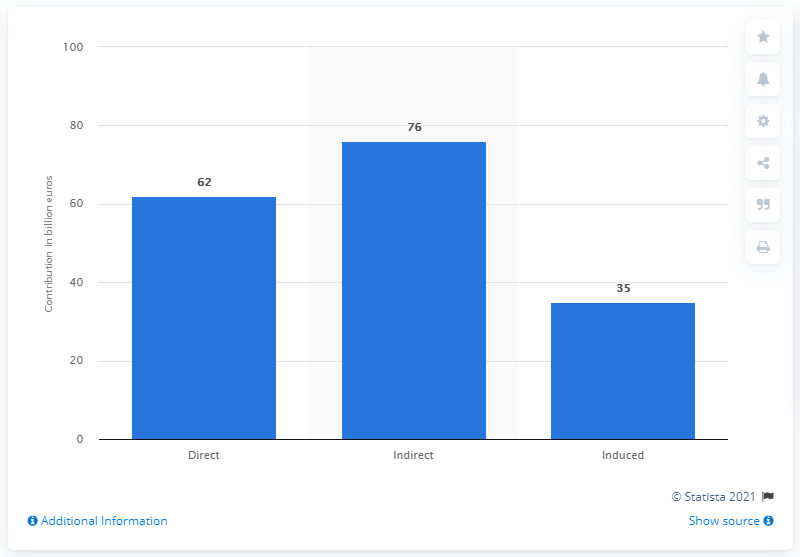Outline some significant characteristics in this image. In 2017, travel and tourism made a significant contribution to the Spanish economy, amounting to X%. 